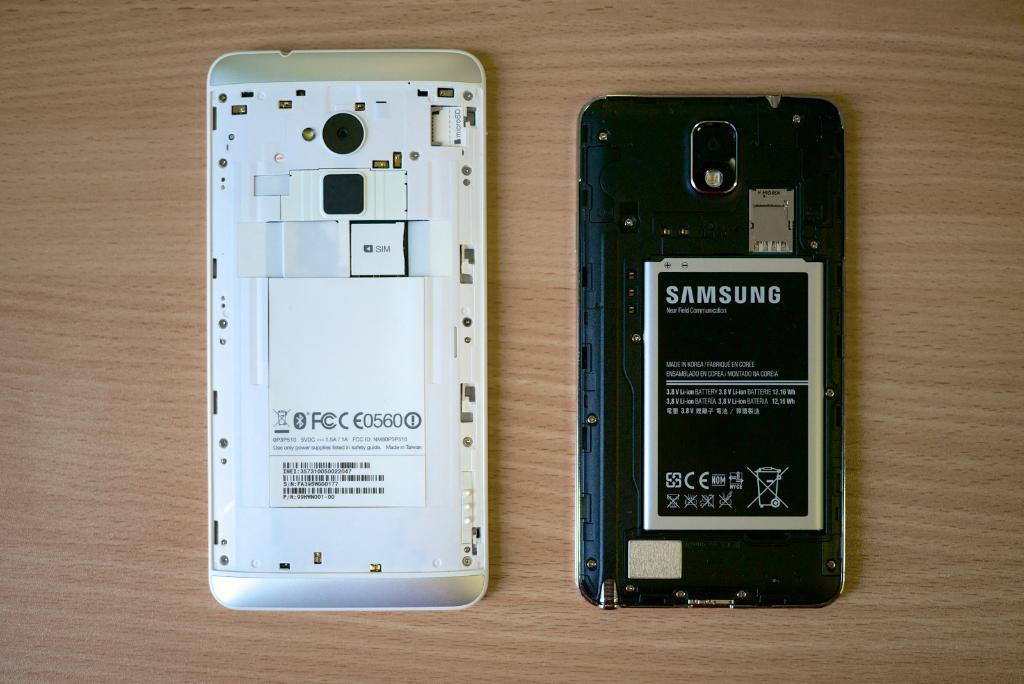<image>
Offer a succinct explanation of the picture presented. A Samsung battery can be seen inside a phone. 